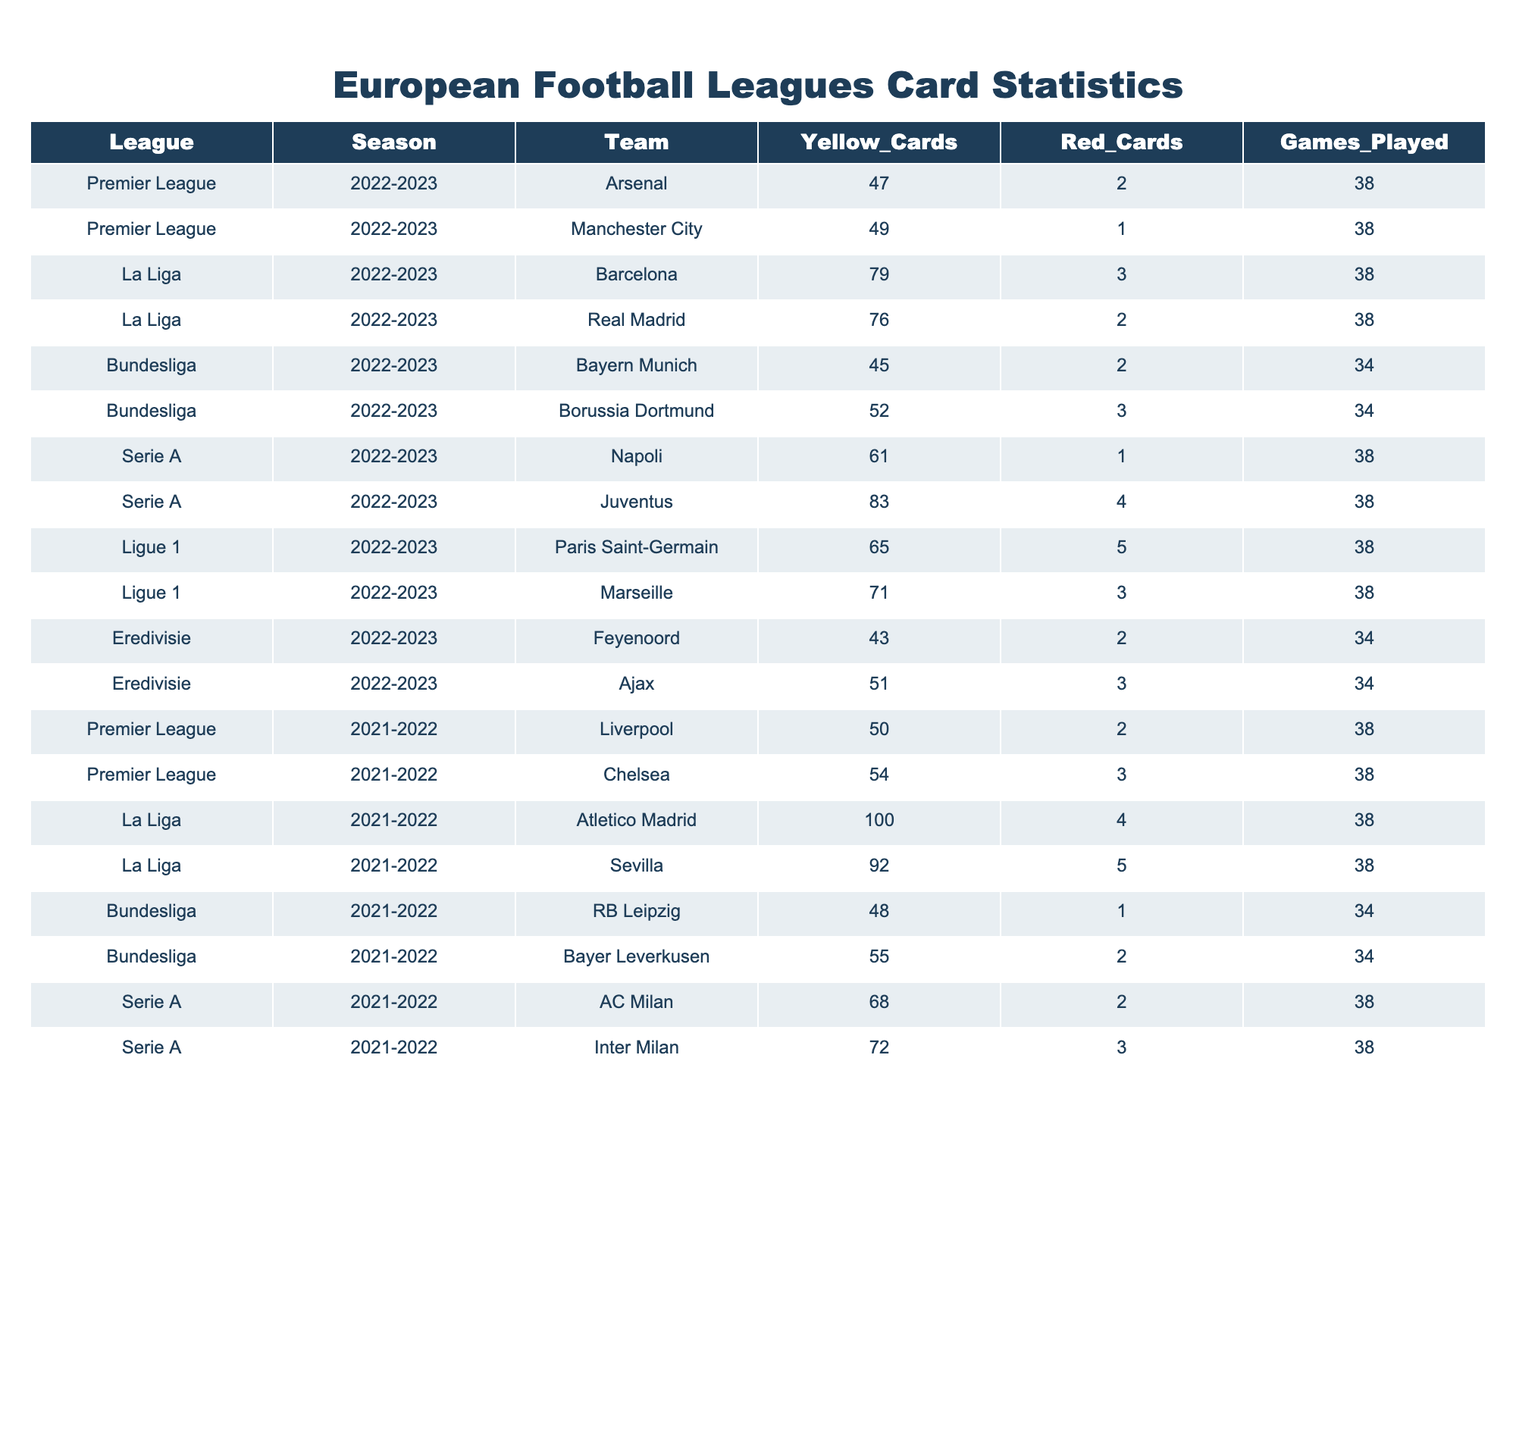What team received the most yellow cards in the Premier League for the 2022-2023 season? Arsenal received 47 yellow cards while Manchester City received 49. Therefore, the team with the most yellow cards is Manchester City.
Answer: Manchester City What is the total number of red cards issued in La Liga for the 2021-2022 season? Atletico Madrid issued 4 red cards, Sevilla issued 5 red cards, making a total of 4 + 5 = 9 red cards.
Answer: 9 Which team in Serie A had the highest number of combined yellow and red cards in the 2022-2023 season? Juventus received 83 yellow cards and 4 red cards, totaling 83 + 4 = 87. Napoli received 61 yellow cards and 1 red card, totaling 61 + 1 = 62. Thus, Juventus had the highest combined total with 87.
Answer: Juventus Which league had the highest average number of yellow cards per game in the 2022-2023 season? In La Liga, Barcelona had 79 yellow cards in 38 games (average 79/38 ≈ 2.08) and Real Madrid had 76 yellow cards (average 76/38 ≈ 2.0). In the Premier League, Arsenal had 47 (average 47/38 ≈ 1.24) and Manchester City had 49 (average 49/38 ≈ 1.29). Calculating all averages reveals that La Liga's average (≈ 2.04) is higher than the Premier League (≈ 1.26).
Answer: La Liga Did any team in the Bundesliga have more red cards than yellow cards in the 2021-2022 season? RB Leipzig had 1 red card and 48 yellow cards, and Bayer Leverkusen had 2 red cards and 55 yellow cards. In both cases, red cards were fewer than yellow cards. Therefore, no team had more red cards than yellow cards.
Answer: No What is the difference in the number of yellow cards received by Atletico Madrid and Sevilla in the 2021-2022 season? Atletico Madrid received 100 yellow cards, while Sevilla received 92 yellow cards. The difference is 100 - 92 = 8.
Answer: 8 Which team in Ligue 1 had the fewest yellow cards during the 2022-2023 season? Paris Saint-Germain received 65 yellow cards and Marseille received 71 yellow cards. Therefore, Paris Saint-Germain had the fewer yellow cards.
Answer: Paris Saint-Germain What is the total number of yellow cards received by Bayern Munich and Borussia Dortmund in the Bundesliga for the 2022-2023 season? Bayern Munich received 45 yellow cards and Borussia Dortmund received 52 yellow cards. Adding these gives 45 + 52 = 97 yellow cards.
Answer: 97 Which team had the highest number of games played with red cards in the Eredivisie during the 2022-2023 season? Feyenoord had 2 red cards in 34 games, while Ajax had 3 red cards in 34 games. Both teams played the same number of games, but Ajax had more red cards.
Answer: Ajax Were there any teams in the Serie A for the 2021-2022 season that received more than 3 red cards? AC Milan received 2 red cards and Inter Milan received 3 red cards. Since neither team exceeded 3 red cards, the answer is no.
Answer: No 